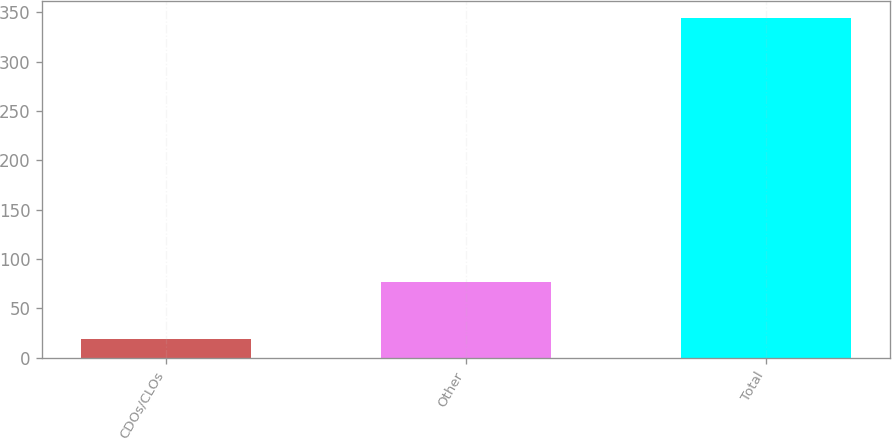Convert chart. <chart><loc_0><loc_0><loc_500><loc_500><bar_chart><fcel>CDOs/CLOs<fcel>Other<fcel>Total<nl><fcel>19<fcel>77<fcel>344<nl></chart> 